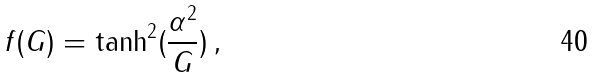Convert formula to latex. <formula><loc_0><loc_0><loc_500><loc_500>f ( G ) = \tanh ^ { 2 } ( \frac { \alpha ^ { 2 } } { G } ) \, ,</formula> 